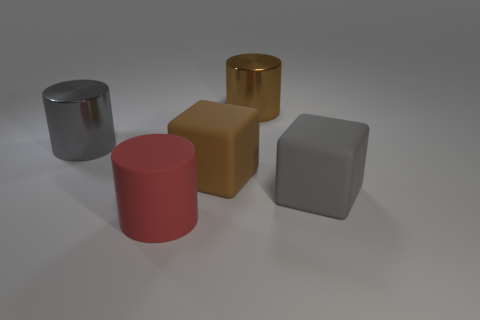Is the number of brown blocks in front of the red cylinder less than the number of gray rubber cubes?
Your answer should be very brief. Yes. What is the large gray cylinder made of?
Give a very brief answer. Metal. The big matte cylinder has what color?
Provide a succinct answer. Red. What is the color of the object that is both behind the big gray block and on the left side of the brown rubber cube?
Your answer should be compact. Gray. Does the gray cube have the same material as the large gray object left of the brown metallic thing?
Provide a succinct answer. No. There is a rubber cube to the left of the large cylinder right of the large brown rubber thing; what is its size?
Ensure brevity in your answer.  Large. Is the material of the large cylinder that is right of the red thing the same as the gray object that is right of the gray cylinder?
Provide a succinct answer. No. There is a large cylinder that is both on the left side of the big brown cylinder and behind the big gray rubber cube; what is its material?
Your answer should be compact. Metal. Is the shape of the red object the same as the matte thing behind the large gray cube?
Provide a succinct answer. No. What material is the big gray thing that is to the left of the large brown cube behind the big gray thing that is on the right side of the big brown shiny thing?
Your response must be concise. Metal. 